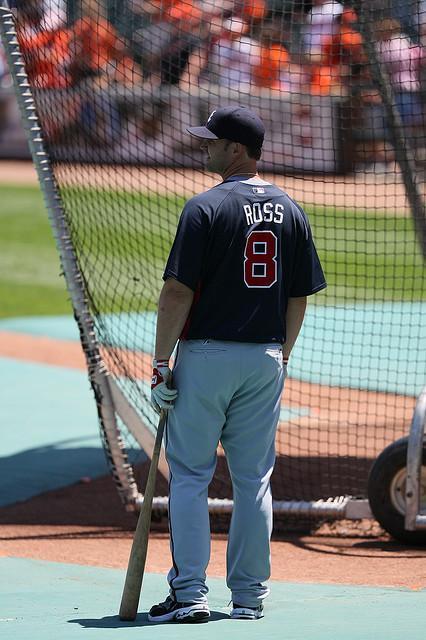How many people are visible?
Give a very brief answer. 4. 